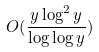Convert formula to latex. <formula><loc_0><loc_0><loc_500><loc_500>O ( \frac { y \log ^ { 2 } y } { \log \log y } )</formula> 